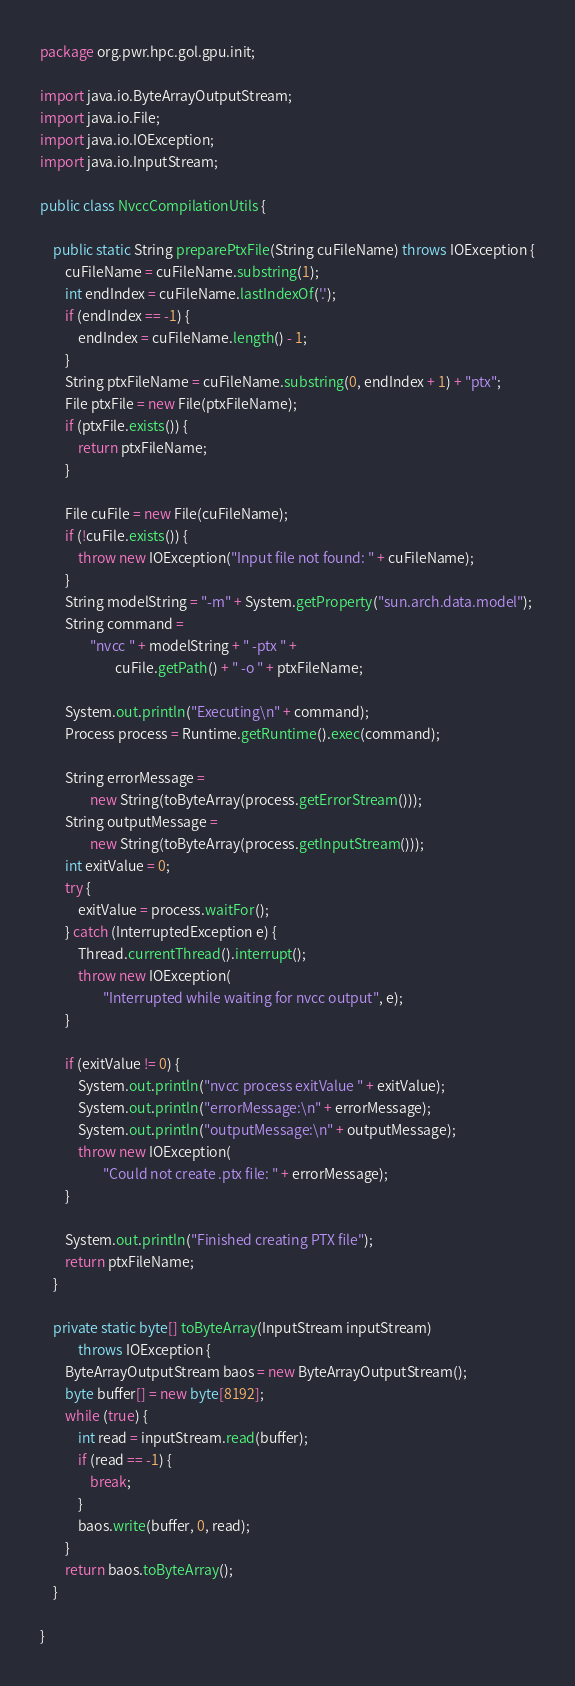<code> <loc_0><loc_0><loc_500><loc_500><_Java_>package org.pwr.hpc.gol.gpu.init;

import java.io.ByteArrayOutputStream;
import java.io.File;
import java.io.IOException;
import java.io.InputStream;

public class NvccCompilationUtils {

    public static String preparePtxFile(String cuFileName) throws IOException {
        cuFileName = cuFileName.substring(1);
        int endIndex = cuFileName.lastIndexOf('.');
        if (endIndex == -1) {
            endIndex = cuFileName.length() - 1;
        }
        String ptxFileName = cuFileName.substring(0, endIndex + 1) + "ptx";
        File ptxFile = new File(ptxFileName);
        if (ptxFile.exists()) {
            return ptxFileName;
        }

        File cuFile = new File(cuFileName);
        if (!cuFile.exists()) {
            throw new IOException("Input file not found: " + cuFileName);
        }
        String modelString = "-m" + System.getProperty("sun.arch.data.model");
        String command =
                "nvcc " + modelString + " -ptx " +
                        cuFile.getPath() + " -o " + ptxFileName;

        System.out.println("Executing\n" + command);
        Process process = Runtime.getRuntime().exec(command);

        String errorMessage =
                new String(toByteArray(process.getErrorStream()));
        String outputMessage =
                new String(toByteArray(process.getInputStream()));
        int exitValue = 0;
        try {
            exitValue = process.waitFor();
        } catch (InterruptedException e) {
            Thread.currentThread().interrupt();
            throw new IOException(
                    "Interrupted while waiting for nvcc output", e);
        }

        if (exitValue != 0) {
            System.out.println("nvcc process exitValue " + exitValue);
            System.out.println("errorMessage:\n" + errorMessage);
            System.out.println("outputMessage:\n" + outputMessage);
            throw new IOException(
                    "Could not create .ptx file: " + errorMessage);
        }

        System.out.println("Finished creating PTX file");
        return ptxFileName;
    }

    private static byte[] toByteArray(InputStream inputStream)
            throws IOException {
        ByteArrayOutputStream baos = new ByteArrayOutputStream();
        byte buffer[] = new byte[8192];
        while (true) {
            int read = inputStream.read(buffer);
            if (read == -1) {
                break;
            }
            baos.write(buffer, 0, read);
        }
        return baos.toByteArray();
    }

}
</code> 